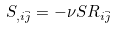Convert formula to latex. <formula><loc_0><loc_0><loc_500><loc_500>S _ { , i \bar { j } } = - \nu S R _ { i \bar { j } }</formula> 